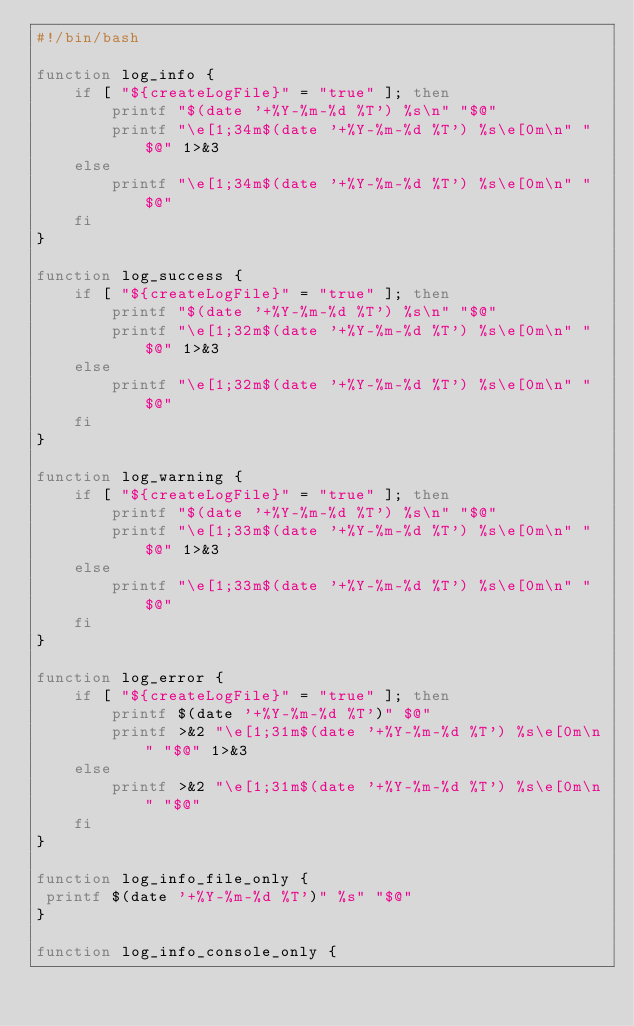<code> <loc_0><loc_0><loc_500><loc_500><_Bash_>#!/bin/bash

function log_info {
    if [ "${createLogFile}" = "true" ]; then 
        printf "$(date '+%Y-%m-%d %T') %s\n" "$@"
        printf "\e[1;34m$(date '+%Y-%m-%d %T') %s\e[0m\n" "$@" 1>&3
    else 
        printf "\e[1;34m$(date '+%Y-%m-%d %T') %s\e[0m\n" "$@"
    fi
}

function log_success {
    if [ "${createLogFile}" = "true" ]; then 
        printf "$(date '+%Y-%m-%d %T') %s\n" "$@"
        printf "\e[1;32m$(date '+%Y-%m-%d %T') %s\e[0m\n" "$@" 1>&3
    else 
        printf "\e[1;32m$(date '+%Y-%m-%d %T') %s\e[0m\n" "$@"
    fi
}

function log_warning {
    if [ "${createLogFile}" = "true" ]; then 
        printf "$(date '+%Y-%m-%d %T') %s\n" "$@"
        printf "\e[1;33m$(date '+%Y-%m-%d %T') %s\e[0m\n" "$@" 1>&3
    else 
        printf "\e[1;33m$(date '+%Y-%m-%d %T') %s\e[0m\n" "$@"
    fi
}

function log_error {
    if [ "${createLogFile}" = "true" ]; then 
        printf $(date '+%Y-%m-%d %T')" $@"
        printf >&2 "\e[1;31m$(date '+%Y-%m-%d %T') %s\e[0m\n" "$@" 1>&3
    else 
        printf >&2 "\e[1;31m$(date '+%Y-%m-%d %T') %s\e[0m\n" "$@"
    fi
}

function log_info_file_only {
 printf $(date '+%Y-%m-%d %T')" %s" "$@" 
}

function log_info_console_only {</code> 